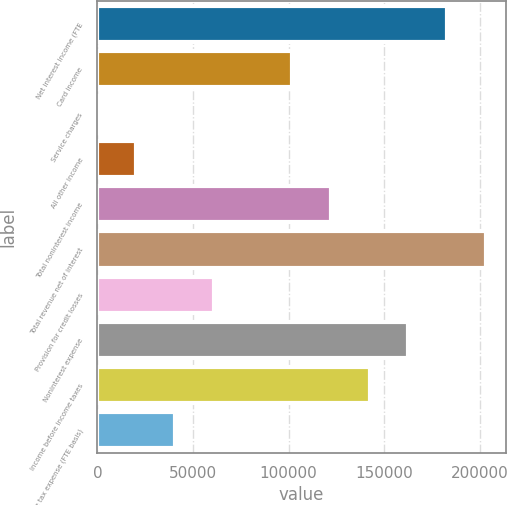<chart> <loc_0><loc_0><loc_500><loc_500><bar_chart><fcel>Net interest income (FTE<fcel>Card income<fcel>Service charges<fcel>All other income<fcel>Total noninterest income<fcel>Total revenue net of interest<fcel>Provision for credit losses<fcel>Noninterest expense<fcel>Income before income taxes<fcel>Income tax expense (FTE basis)<nl><fcel>182997<fcel>101666<fcel>1<fcel>20333.9<fcel>121998<fcel>203330<fcel>60999.7<fcel>162664<fcel>142331<fcel>40666.8<nl></chart> 